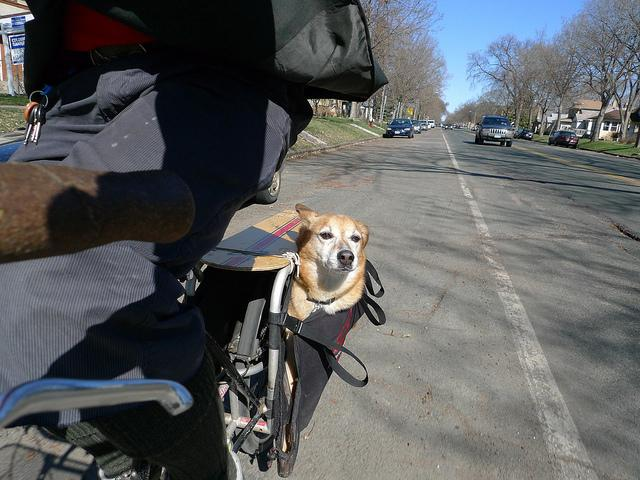How is the dog probably traveling?

Choices:
A) motorcycle
B) bike
C) scooter
D) skateboard bike 